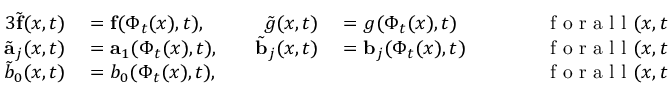Convert formula to latex. <formula><loc_0><loc_0><loc_500><loc_500>\begin{array} { r l r l r l } { { 3 } \tilde { f } ( x , t ) } & = f ( \Phi _ { t } ( x ) , t ) , } & { \quad \tilde { g } ( x , t ) } & = g ( \Phi _ { t } ( x ) , t ) } & { \quad } & f o r a l l ( x , t ) \in \Omega _ { 0 } ^ { \pm } \times ( 0 , T ) , } \\ { \tilde { a } _ { j } ( x , t ) } & = a _ { 1 } ( \Phi _ { t } ( x ) , t ) , } & { \quad \tilde { b } _ { j } ( x , t ) } & = b _ { j } ( \Phi _ { t } ( x ) , t ) } & { \quad } & f o r a l l ( x , t ) \in \Gamma _ { 0 } \times ( 0 , T ) , j = 1 , 2 , } \\ { \tilde { b } _ { 0 } ( x , t ) } & = b _ { 0 } ( \Phi _ { t } ( x ) , t ) , } & { \quad } & f o r a l l ( x , t ) \in \Gamma _ { 0 } \times ( 0 , T ) . } \end{array}</formula> 